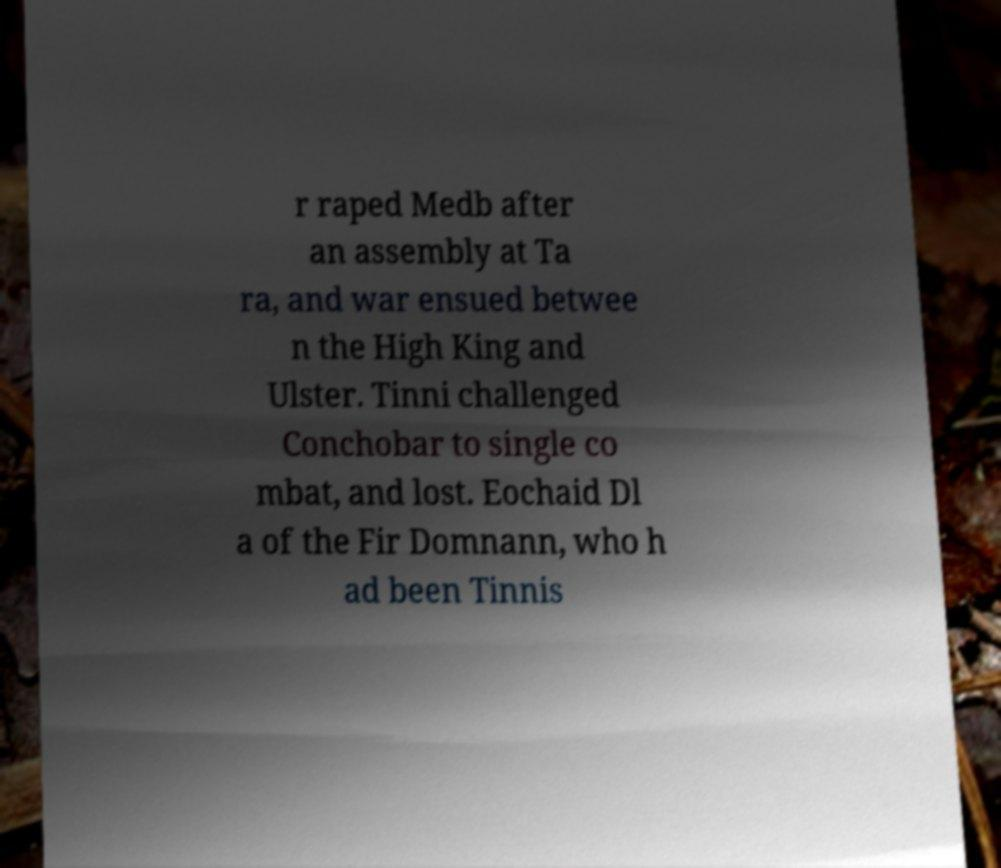Could you assist in decoding the text presented in this image and type it out clearly? r raped Medb after an assembly at Ta ra, and war ensued betwee n the High King and Ulster. Tinni challenged Conchobar to single co mbat, and lost. Eochaid Dl a of the Fir Domnann, who h ad been Tinnis 